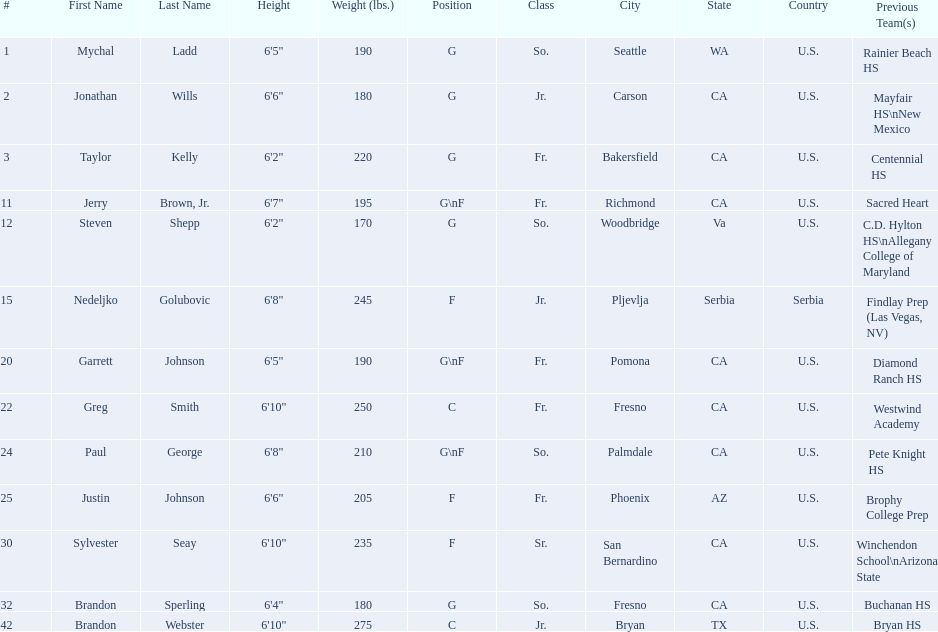Who are all the players in the 2009-10 fresno state bulldogs men's basketball team? Mychal Ladd, Jonathan Wills, Taylor Kelly, Jerry Brown, Jr., Steven Shepp, Nedeljko Golubovic, Garrett Johnson, Greg Smith, Paul George, Justin Johnson, Sylvester Seay, Brandon Sperling, Brandon Webster. Of these players, who are the ones who play forward? Jerry Brown, Jr., Nedeljko Golubovic, Garrett Johnson, Paul George, Justin Johnson, Sylvester Seay. Of these players, which ones only play forward and no other position? Nedeljko Golubovic, Justin Johnson, Sylvester Seay. Of these players, who is the shortest? Justin Johnson. 